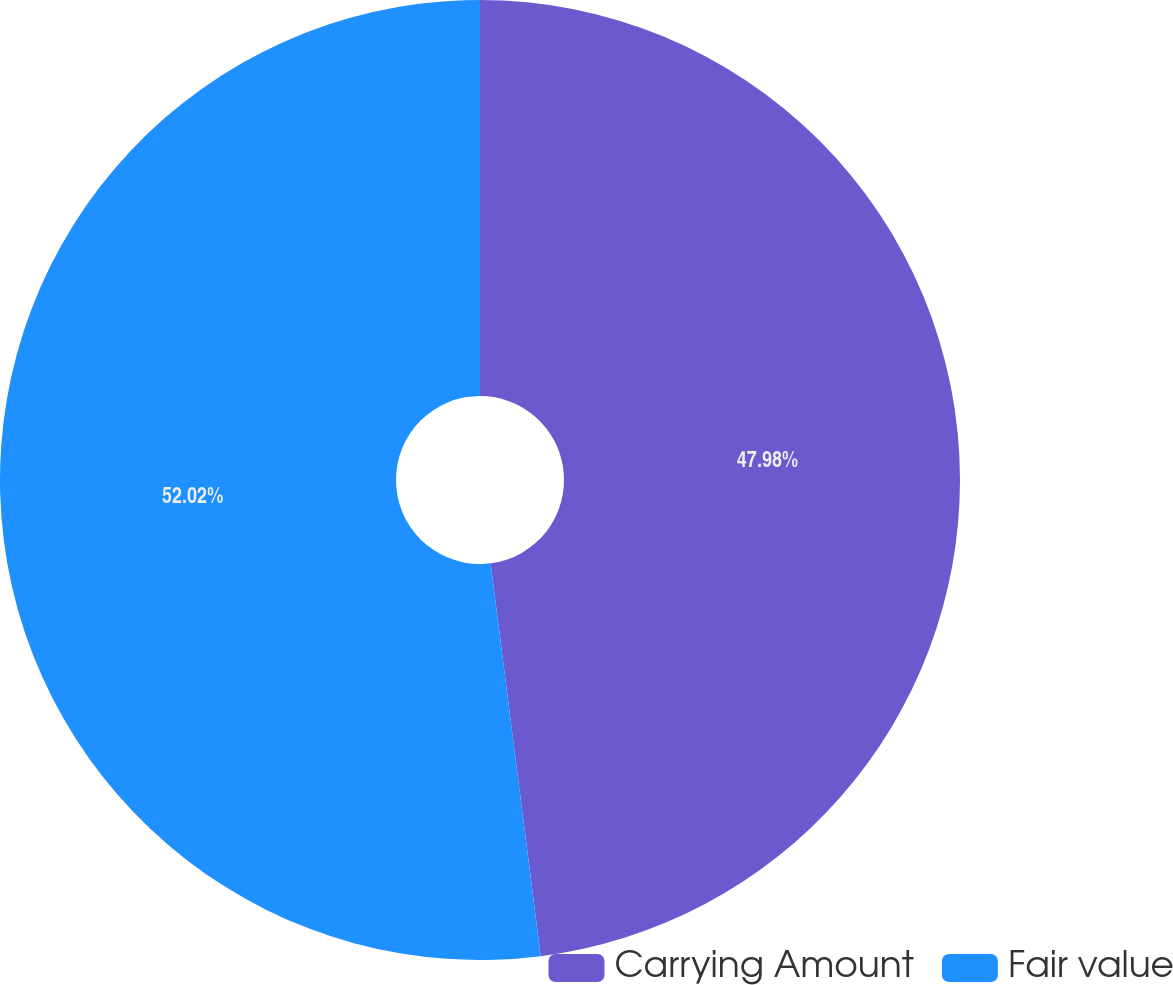<chart> <loc_0><loc_0><loc_500><loc_500><pie_chart><fcel>Carrying Amount<fcel>Fair value<nl><fcel>47.98%<fcel>52.02%<nl></chart> 